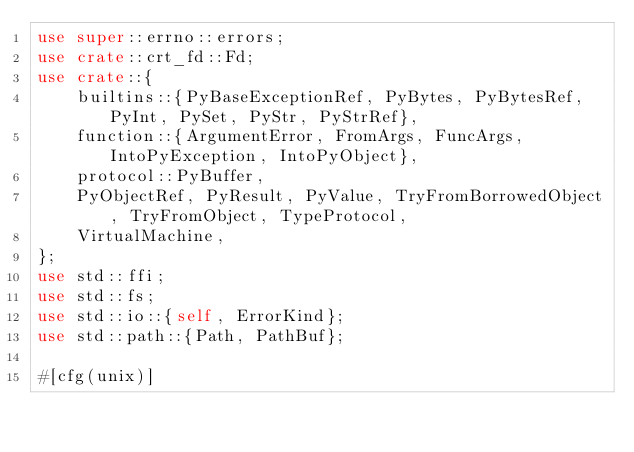Convert code to text. <code><loc_0><loc_0><loc_500><loc_500><_Rust_>use super::errno::errors;
use crate::crt_fd::Fd;
use crate::{
    builtins::{PyBaseExceptionRef, PyBytes, PyBytesRef, PyInt, PySet, PyStr, PyStrRef},
    function::{ArgumentError, FromArgs, FuncArgs, IntoPyException, IntoPyObject},
    protocol::PyBuffer,
    PyObjectRef, PyResult, PyValue, TryFromBorrowedObject, TryFromObject, TypeProtocol,
    VirtualMachine,
};
use std::ffi;
use std::fs;
use std::io::{self, ErrorKind};
use std::path::{Path, PathBuf};

#[cfg(unix)]</code> 